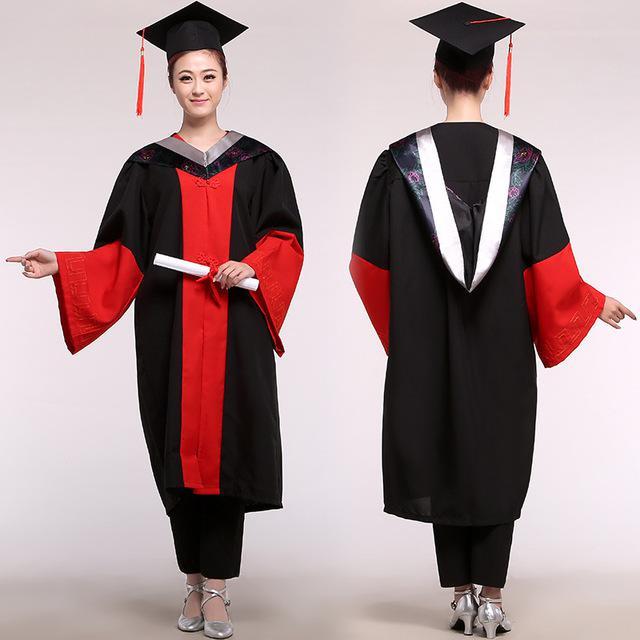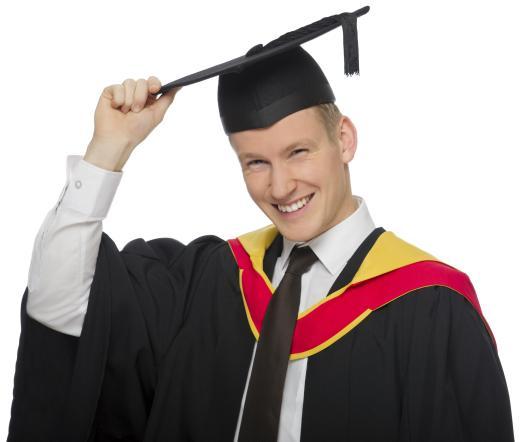The first image is the image on the left, the second image is the image on the right. Assess this claim about the two images: "A man is wearing a graduation outfit in one of the images.". Correct or not? Answer yes or no. Yes. 